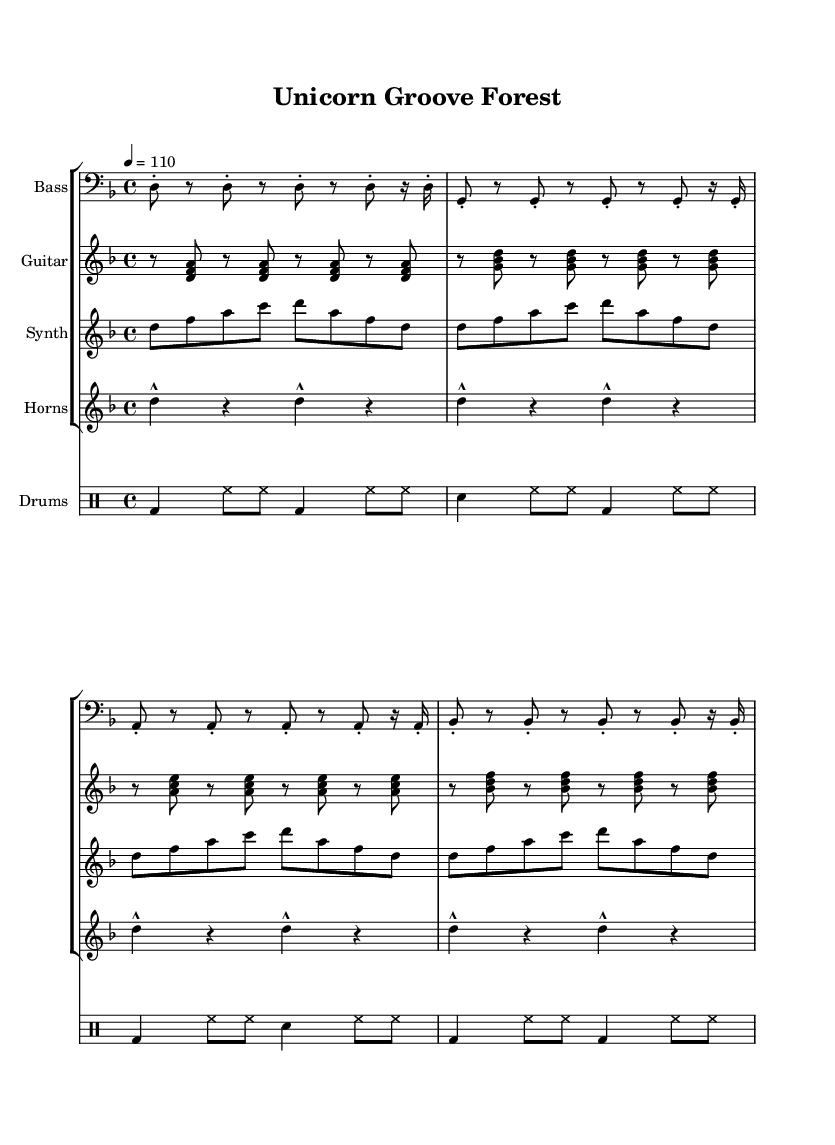What is the key signature of this music? The key signature indicated in the global music instructions shows a D minor key, which has one flat. This can be confirmed by looking at the key signature at the beginning of the staff in the global block.
Answer: D minor What is the time signature of this piece? The time signature is specified in the global section of the code as 4/4, which indicates that there are four beats in each measure and a quarter note gets one beat. This can be confirmed by the notation at the beginning.
Answer: 4/4 What is the tempo marking for this music? The tempo is set at 110 beats per minute, as specified in the global section with "tempo 4 = 110". This means the quarter note is played at a speed of 110 beats per minute.
Answer: 110 How many measures are there in the bass line? The bass line consists of four lines of music, each containing four measures. Thus, there are a total of 16 measures in the bass line section.
Answer: 16 Which instruments are included in this composition? The instruments are specified in the score structure. They include Bass, Guitar, Synth, Horns, and Drums. Each is organized into separate staffs within the score.
Answer: Bass, Guitar, Synth, Horns, Drums What characterizes the groove of this Funk piece? The groove is characterized by syncopated rhythms, laid-back beats, and a combination of bass and rhythm guitar emphasized throughout the score, which aligns with traditional Funk music elements. The bass line and drum patterns particularly embody this groove.
Answer: Syncopation How many times does the synth melody repeat? The synth melody is notated four times in succession, as each line of the melody is identical. The repetition can be observed in the structure of the music notation for the synth within the score.
Answer: 4 times 